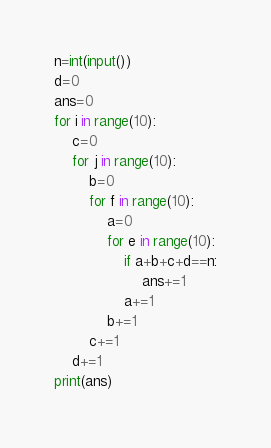<code> <loc_0><loc_0><loc_500><loc_500><_Python_>n=int(input())
d=0
ans=0
for i in range(10):
    c=0
    for j in range(10):
        b=0
        for f in range(10):
            a=0
            for e in range(10):
                if a+b+c+d==n:
                    ans+=1
                a+=1
            b+=1
        c+=1
    d+=1
print(ans)

</code> 